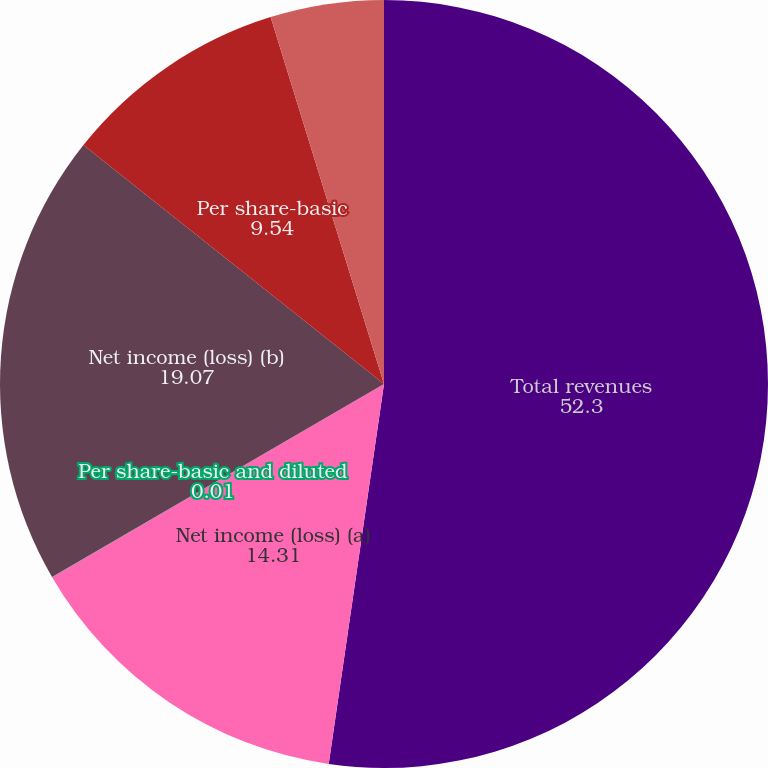<chart> <loc_0><loc_0><loc_500><loc_500><pie_chart><fcel>Total revenues<fcel>Net income (loss) (a)<fcel>Per share-basic and diluted<fcel>Net income (loss) (b)<fcel>Per share-basic<fcel>Per share-diluted<nl><fcel>52.3%<fcel>14.31%<fcel>0.01%<fcel>19.07%<fcel>9.54%<fcel>4.77%<nl></chart> 